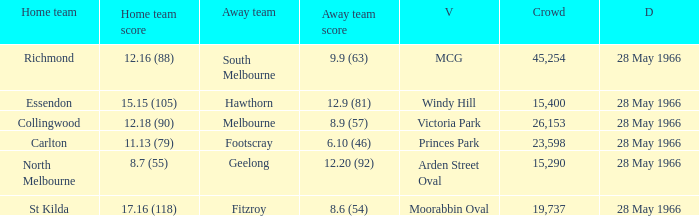Which Venue has a Home team of essendon? Windy Hill. Can you give me this table as a dict? {'header': ['Home team', 'Home team score', 'Away team', 'Away team score', 'V', 'Crowd', 'D'], 'rows': [['Richmond', '12.16 (88)', 'South Melbourne', '9.9 (63)', 'MCG', '45,254', '28 May 1966'], ['Essendon', '15.15 (105)', 'Hawthorn', '12.9 (81)', 'Windy Hill', '15,400', '28 May 1966'], ['Collingwood', '12.18 (90)', 'Melbourne', '8.9 (57)', 'Victoria Park', '26,153', '28 May 1966'], ['Carlton', '11.13 (79)', 'Footscray', '6.10 (46)', 'Princes Park', '23,598', '28 May 1966'], ['North Melbourne', '8.7 (55)', 'Geelong', '12.20 (92)', 'Arden Street Oval', '15,290', '28 May 1966'], ['St Kilda', '17.16 (118)', 'Fitzroy', '8.6 (54)', 'Moorabbin Oval', '19,737', '28 May 1966']]} 